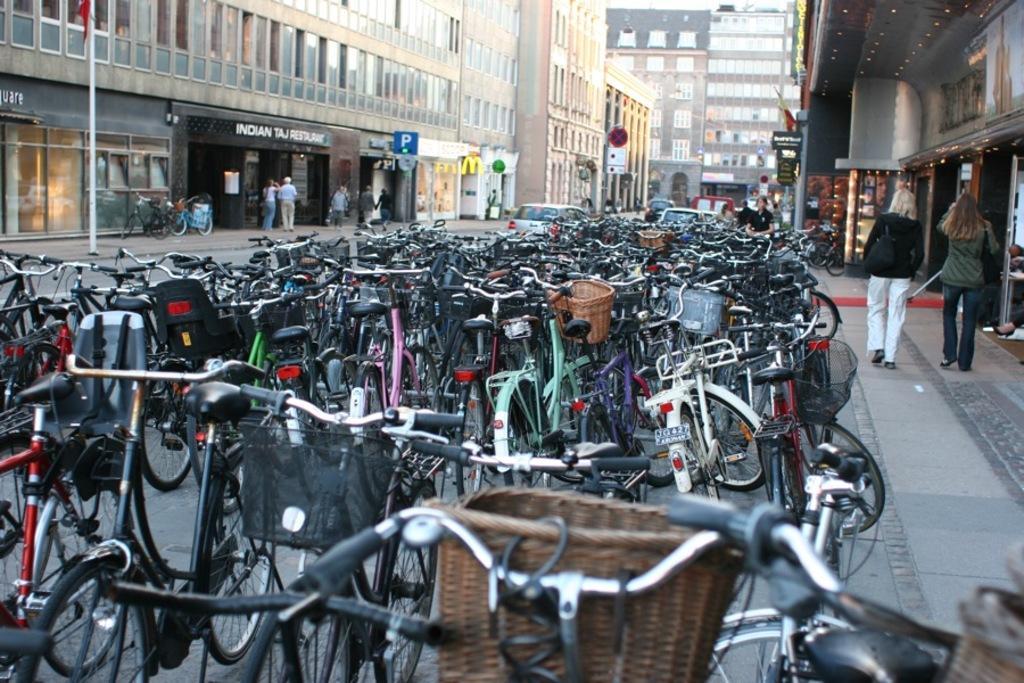Could you give a brief overview of what you see in this image? In this image, we can see persons wearing clothes. There is a pole in the top left of the image. There are cycles and cars in between buildings. 